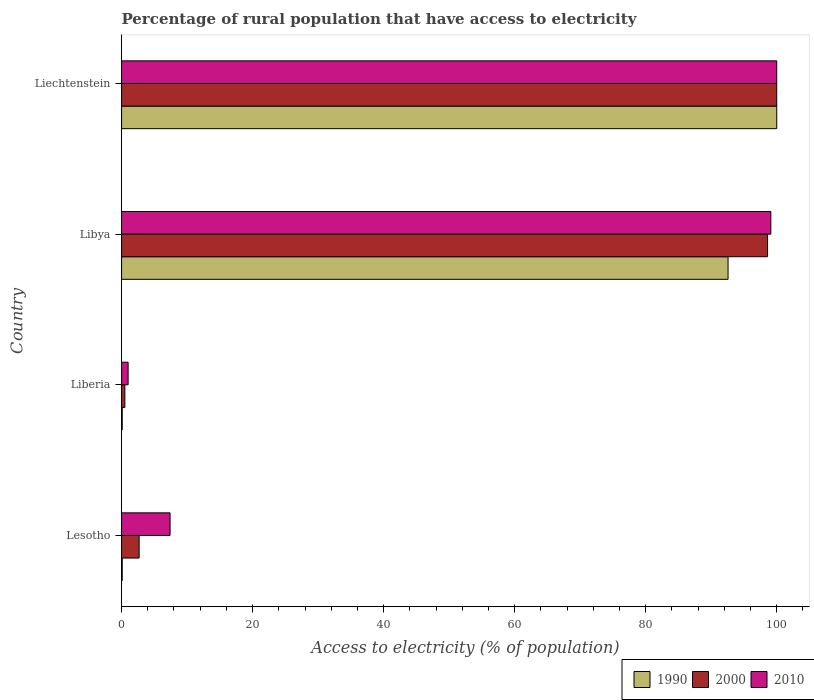Are the number of bars on each tick of the Y-axis equal?
Give a very brief answer. Yes. What is the label of the 4th group of bars from the top?
Make the answer very short. Lesotho. In how many cases, is the number of bars for a given country not equal to the number of legend labels?
Your answer should be very brief. 0. What is the percentage of rural population that have access to electricity in 2010 in Liechtenstein?
Your answer should be very brief. 100. Across all countries, what is the maximum percentage of rural population that have access to electricity in 1990?
Your answer should be compact. 100. In which country was the percentage of rural population that have access to electricity in 2000 maximum?
Your answer should be very brief. Liechtenstein. In which country was the percentage of rural population that have access to electricity in 2010 minimum?
Offer a very short reply. Liberia. What is the total percentage of rural population that have access to electricity in 1990 in the graph?
Give a very brief answer. 192.77. What is the difference between the percentage of rural population that have access to electricity in 2000 in Lesotho and that in Libya?
Ensure brevity in your answer.  -95.92. What is the difference between the percentage of rural population that have access to electricity in 1990 in Lesotho and the percentage of rural population that have access to electricity in 2010 in Libya?
Offer a terse response. -99. What is the average percentage of rural population that have access to electricity in 2000 per country?
Make the answer very short. 50.45. In how many countries, is the percentage of rural population that have access to electricity in 2010 greater than 92 %?
Make the answer very short. 2. Is the percentage of rural population that have access to electricity in 2000 in Lesotho less than that in Liberia?
Give a very brief answer. No. Is the difference between the percentage of rural population that have access to electricity in 1990 in Lesotho and Libya greater than the difference between the percentage of rural population that have access to electricity in 2010 in Lesotho and Libya?
Provide a succinct answer. No. What is the difference between the highest and the second highest percentage of rural population that have access to electricity in 1990?
Keep it short and to the point. 7.43. What is the difference between the highest and the lowest percentage of rural population that have access to electricity in 1990?
Give a very brief answer. 99.9. In how many countries, is the percentage of rural population that have access to electricity in 2000 greater than the average percentage of rural population that have access to electricity in 2000 taken over all countries?
Give a very brief answer. 2. Is the sum of the percentage of rural population that have access to electricity in 2000 in Liberia and Liechtenstein greater than the maximum percentage of rural population that have access to electricity in 2010 across all countries?
Your answer should be very brief. Yes. What does the 3rd bar from the top in Libya represents?
Your answer should be very brief. 1990. What does the 2nd bar from the bottom in Liberia represents?
Your answer should be compact. 2000. Is it the case that in every country, the sum of the percentage of rural population that have access to electricity in 2010 and percentage of rural population that have access to electricity in 2000 is greater than the percentage of rural population that have access to electricity in 1990?
Your answer should be very brief. Yes. How many bars are there?
Provide a succinct answer. 12. Are all the bars in the graph horizontal?
Give a very brief answer. Yes. What is the difference between two consecutive major ticks on the X-axis?
Offer a terse response. 20. Are the values on the major ticks of X-axis written in scientific E-notation?
Make the answer very short. No. How are the legend labels stacked?
Offer a very short reply. Horizontal. What is the title of the graph?
Make the answer very short. Percentage of rural population that have access to electricity. What is the label or title of the X-axis?
Your answer should be very brief. Access to electricity (% of population). What is the Access to electricity (% of population) in 1990 in Lesotho?
Ensure brevity in your answer.  0.1. What is the Access to electricity (% of population) of 2000 in Lesotho?
Keep it short and to the point. 2.68. What is the Access to electricity (% of population) of 2010 in Lesotho?
Provide a short and direct response. 7.4. What is the Access to electricity (% of population) in 2000 in Liberia?
Offer a terse response. 0.5. What is the Access to electricity (% of population) of 1990 in Libya?
Offer a terse response. 92.57. What is the Access to electricity (% of population) in 2000 in Libya?
Provide a short and direct response. 98.6. What is the Access to electricity (% of population) in 2010 in Libya?
Provide a succinct answer. 99.1. What is the Access to electricity (% of population) in 1990 in Liechtenstein?
Ensure brevity in your answer.  100. What is the Access to electricity (% of population) in 2000 in Liechtenstein?
Keep it short and to the point. 100. Across all countries, what is the maximum Access to electricity (% of population) of 2000?
Keep it short and to the point. 100. Across all countries, what is the maximum Access to electricity (% of population) of 2010?
Provide a succinct answer. 100. Across all countries, what is the minimum Access to electricity (% of population) of 1990?
Your response must be concise. 0.1. Across all countries, what is the minimum Access to electricity (% of population) in 2000?
Your response must be concise. 0.5. What is the total Access to electricity (% of population) in 1990 in the graph?
Offer a very short reply. 192.77. What is the total Access to electricity (% of population) of 2000 in the graph?
Your response must be concise. 201.78. What is the total Access to electricity (% of population) of 2010 in the graph?
Keep it short and to the point. 207.5. What is the difference between the Access to electricity (% of population) in 2000 in Lesotho and that in Liberia?
Make the answer very short. 2.18. What is the difference between the Access to electricity (% of population) of 2010 in Lesotho and that in Liberia?
Ensure brevity in your answer.  6.4. What is the difference between the Access to electricity (% of population) of 1990 in Lesotho and that in Libya?
Your answer should be compact. -92.47. What is the difference between the Access to electricity (% of population) in 2000 in Lesotho and that in Libya?
Your answer should be very brief. -95.92. What is the difference between the Access to electricity (% of population) of 2010 in Lesotho and that in Libya?
Your answer should be very brief. -91.7. What is the difference between the Access to electricity (% of population) in 1990 in Lesotho and that in Liechtenstein?
Make the answer very short. -99.9. What is the difference between the Access to electricity (% of population) in 2000 in Lesotho and that in Liechtenstein?
Offer a very short reply. -97.32. What is the difference between the Access to electricity (% of population) in 2010 in Lesotho and that in Liechtenstein?
Make the answer very short. -92.6. What is the difference between the Access to electricity (% of population) in 1990 in Liberia and that in Libya?
Your answer should be compact. -92.47. What is the difference between the Access to electricity (% of population) of 2000 in Liberia and that in Libya?
Offer a terse response. -98.1. What is the difference between the Access to electricity (% of population) of 2010 in Liberia and that in Libya?
Offer a very short reply. -98.1. What is the difference between the Access to electricity (% of population) of 1990 in Liberia and that in Liechtenstein?
Keep it short and to the point. -99.9. What is the difference between the Access to electricity (% of population) of 2000 in Liberia and that in Liechtenstein?
Your answer should be very brief. -99.5. What is the difference between the Access to electricity (% of population) of 2010 in Liberia and that in Liechtenstein?
Provide a succinct answer. -99. What is the difference between the Access to electricity (% of population) of 1990 in Libya and that in Liechtenstein?
Make the answer very short. -7.43. What is the difference between the Access to electricity (% of population) of 2000 in Libya and that in Liechtenstein?
Provide a short and direct response. -1.4. What is the difference between the Access to electricity (% of population) of 1990 in Lesotho and the Access to electricity (% of population) of 2000 in Liberia?
Offer a very short reply. -0.4. What is the difference between the Access to electricity (% of population) of 2000 in Lesotho and the Access to electricity (% of population) of 2010 in Liberia?
Your response must be concise. 1.68. What is the difference between the Access to electricity (% of population) in 1990 in Lesotho and the Access to electricity (% of population) in 2000 in Libya?
Offer a very short reply. -98.5. What is the difference between the Access to electricity (% of population) of 1990 in Lesotho and the Access to electricity (% of population) of 2010 in Libya?
Provide a short and direct response. -99. What is the difference between the Access to electricity (% of population) of 2000 in Lesotho and the Access to electricity (% of population) of 2010 in Libya?
Make the answer very short. -96.42. What is the difference between the Access to electricity (% of population) in 1990 in Lesotho and the Access to electricity (% of population) in 2000 in Liechtenstein?
Give a very brief answer. -99.9. What is the difference between the Access to electricity (% of population) in 1990 in Lesotho and the Access to electricity (% of population) in 2010 in Liechtenstein?
Keep it short and to the point. -99.9. What is the difference between the Access to electricity (% of population) of 2000 in Lesotho and the Access to electricity (% of population) of 2010 in Liechtenstein?
Your answer should be compact. -97.32. What is the difference between the Access to electricity (% of population) of 1990 in Liberia and the Access to electricity (% of population) of 2000 in Libya?
Give a very brief answer. -98.5. What is the difference between the Access to electricity (% of population) of 1990 in Liberia and the Access to electricity (% of population) of 2010 in Libya?
Ensure brevity in your answer.  -99. What is the difference between the Access to electricity (% of population) of 2000 in Liberia and the Access to electricity (% of population) of 2010 in Libya?
Ensure brevity in your answer.  -98.6. What is the difference between the Access to electricity (% of population) in 1990 in Liberia and the Access to electricity (% of population) in 2000 in Liechtenstein?
Offer a very short reply. -99.9. What is the difference between the Access to electricity (% of population) in 1990 in Liberia and the Access to electricity (% of population) in 2010 in Liechtenstein?
Provide a succinct answer. -99.9. What is the difference between the Access to electricity (% of population) of 2000 in Liberia and the Access to electricity (% of population) of 2010 in Liechtenstein?
Keep it short and to the point. -99.5. What is the difference between the Access to electricity (% of population) of 1990 in Libya and the Access to electricity (% of population) of 2000 in Liechtenstein?
Offer a very short reply. -7.43. What is the difference between the Access to electricity (% of population) of 1990 in Libya and the Access to electricity (% of population) of 2010 in Liechtenstein?
Provide a short and direct response. -7.43. What is the average Access to electricity (% of population) in 1990 per country?
Offer a very short reply. 48.19. What is the average Access to electricity (% of population) of 2000 per country?
Offer a very short reply. 50.45. What is the average Access to electricity (% of population) of 2010 per country?
Provide a short and direct response. 51.88. What is the difference between the Access to electricity (% of population) of 1990 and Access to electricity (% of population) of 2000 in Lesotho?
Provide a succinct answer. -2.58. What is the difference between the Access to electricity (% of population) of 2000 and Access to electricity (% of population) of 2010 in Lesotho?
Your answer should be very brief. -4.72. What is the difference between the Access to electricity (% of population) in 1990 and Access to electricity (% of population) in 2000 in Libya?
Keep it short and to the point. -6.03. What is the difference between the Access to electricity (% of population) of 1990 and Access to electricity (% of population) of 2010 in Libya?
Provide a succinct answer. -6.53. What is the difference between the Access to electricity (% of population) of 2000 and Access to electricity (% of population) of 2010 in Libya?
Your response must be concise. -0.5. What is the difference between the Access to electricity (% of population) of 1990 and Access to electricity (% of population) of 2000 in Liechtenstein?
Your response must be concise. 0. What is the difference between the Access to electricity (% of population) in 1990 and Access to electricity (% of population) in 2010 in Liechtenstein?
Make the answer very short. 0. What is the ratio of the Access to electricity (% of population) of 2000 in Lesotho to that in Liberia?
Ensure brevity in your answer.  5.36. What is the ratio of the Access to electricity (% of population) in 1990 in Lesotho to that in Libya?
Offer a very short reply. 0. What is the ratio of the Access to electricity (% of population) in 2000 in Lesotho to that in Libya?
Your answer should be compact. 0.03. What is the ratio of the Access to electricity (% of population) in 2010 in Lesotho to that in Libya?
Offer a very short reply. 0.07. What is the ratio of the Access to electricity (% of population) of 1990 in Lesotho to that in Liechtenstein?
Make the answer very short. 0. What is the ratio of the Access to electricity (% of population) in 2000 in Lesotho to that in Liechtenstein?
Your answer should be compact. 0.03. What is the ratio of the Access to electricity (% of population) of 2010 in Lesotho to that in Liechtenstein?
Keep it short and to the point. 0.07. What is the ratio of the Access to electricity (% of population) of 1990 in Liberia to that in Libya?
Keep it short and to the point. 0. What is the ratio of the Access to electricity (% of population) in 2000 in Liberia to that in Libya?
Provide a succinct answer. 0.01. What is the ratio of the Access to electricity (% of population) in 2010 in Liberia to that in Libya?
Offer a terse response. 0.01. What is the ratio of the Access to electricity (% of population) in 1990 in Liberia to that in Liechtenstein?
Give a very brief answer. 0. What is the ratio of the Access to electricity (% of population) in 2000 in Liberia to that in Liechtenstein?
Offer a terse response. 0.01. What is the ratio of the Access to electricity (% of population) in 2010 in Liberia to that in Liechtenstein?
Your answer should be very brief. 0.01. What is the ratio of the Access to electricity (% of population) of 1990 in Libya to that in Liechtenstein?
Ensure brevity in your answer.  0.93. What is the ratio of the Access to electricity (% of population) of 2000 in Libya to that in Liechtenstein?
Your answer should be very brief. 0.99. What is the difference between the highest and the second highest Access to electricity (% of population) of 1990?
Provide a succinct answer. 7.43. What is the difference between the highest and the second highest Access to electricity (% of population) of 2010?
Keep it short and to the point. 0.9. What is the difference between the highest and the lowest Access to electricity (% of population) of 1990?
Your answer should be very brief. 99.9. What is the difference between the highest and the lowest Access to electricity (% of population) in 2000?
Ensure brevity in your answer.  99.5. What is the difference between the highest and the lowest Access to electricity (% of population) in 2010?
Offer a very short reply. 99. 